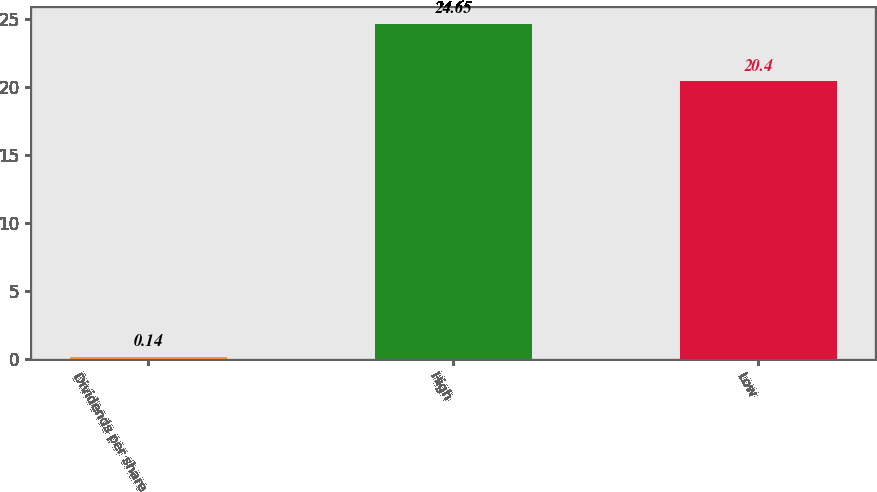Convert chart to OTSL. <chart><loc_0><loc_0><loc_500><loc_500><bar_chart><fcel>Dividends per share<fcel>High<fcel>Low<nl><fcel>0.14<fcel>24.65<fcel>20.4<nl></chart> 